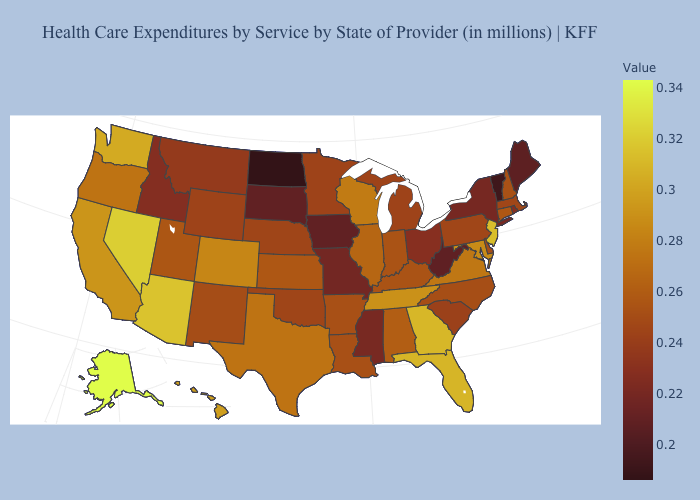Which states hav the highest value in the South?
Answer briefly. Georgia. Is the legend a continuous bar?
Write a very short answer. Yes. Is the legend a continuous bar?
Keep it brief. Yes. Does the map have missing data?
Concise answer only. No. Which states have the lowest value in the Northeast?
Write a very short answer. Vermont. 